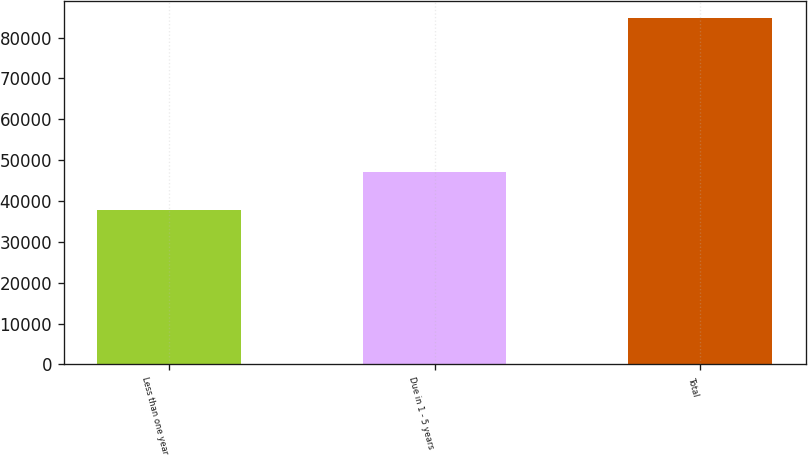<chart> <loc_0><loc_0><loc_500><loc_500><bar_chart><fcel>Less than one year<fcel>Due in 1 - 5 years<fcel>Total<nl><fcel>37694<fcel>47012<fcel>84706<nl></chart> 